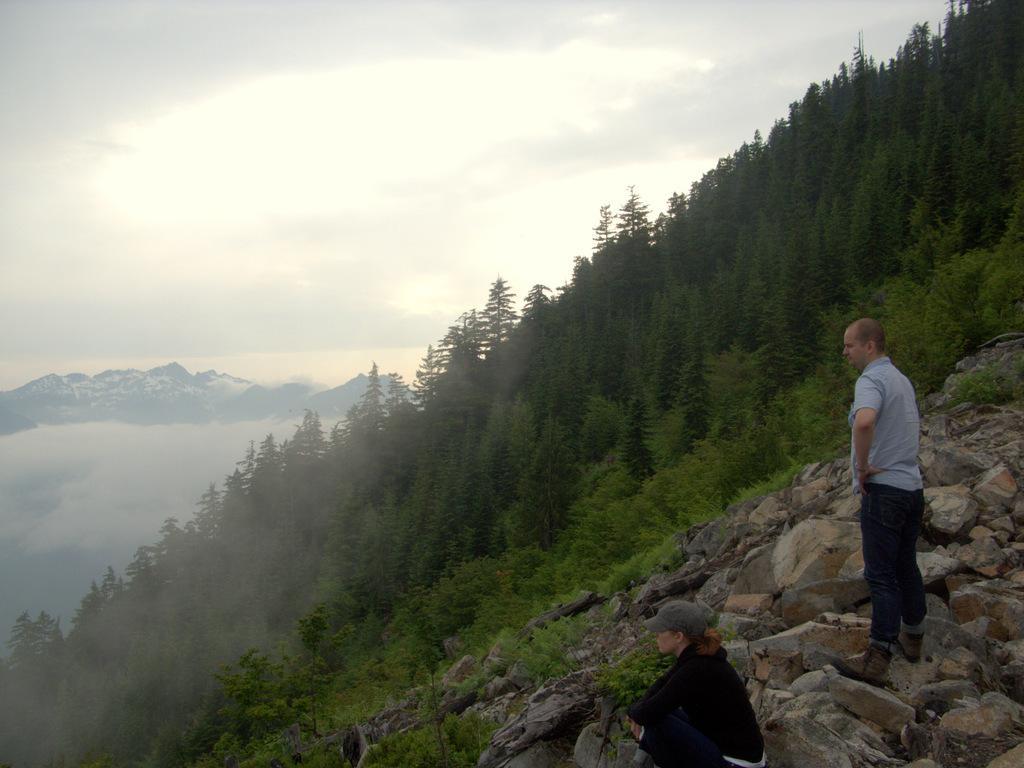Please provide a concise description of this image. In the center of the image we can see a man standing on the hill. At the bottom there is a lady sitting on the rocks. In the background there are hills and sky. 